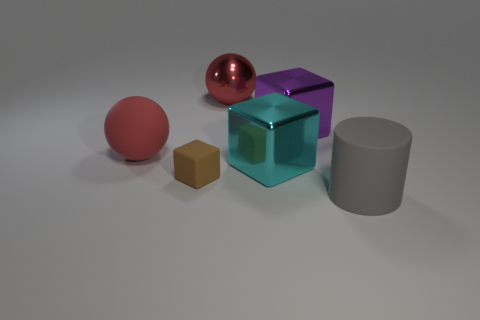Add 2 large matte balls. How many objects exist? 8 Subtract all spheres. How many objects are left? 4 Subtract all small brown objects. Subtract all tiny brown cubes. How many objects are left? 4 Add 1 red rubber things. How many red rubber things are left? 2 Add 4 yellow cubes. How many yellow cubes exist? 4 Subtract 0 yellow blocks. How many objects are left? 6 